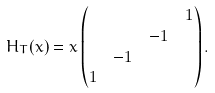<formula> <loc_0><loc_0><loc_500><loc_500>H _ { T } ( x ) & = x \begin{pmatrix} & & & 1 \\ & & - 1 & \\ & - 1 & & \\ 1 & & & \end{pmatrix} .</formula> 